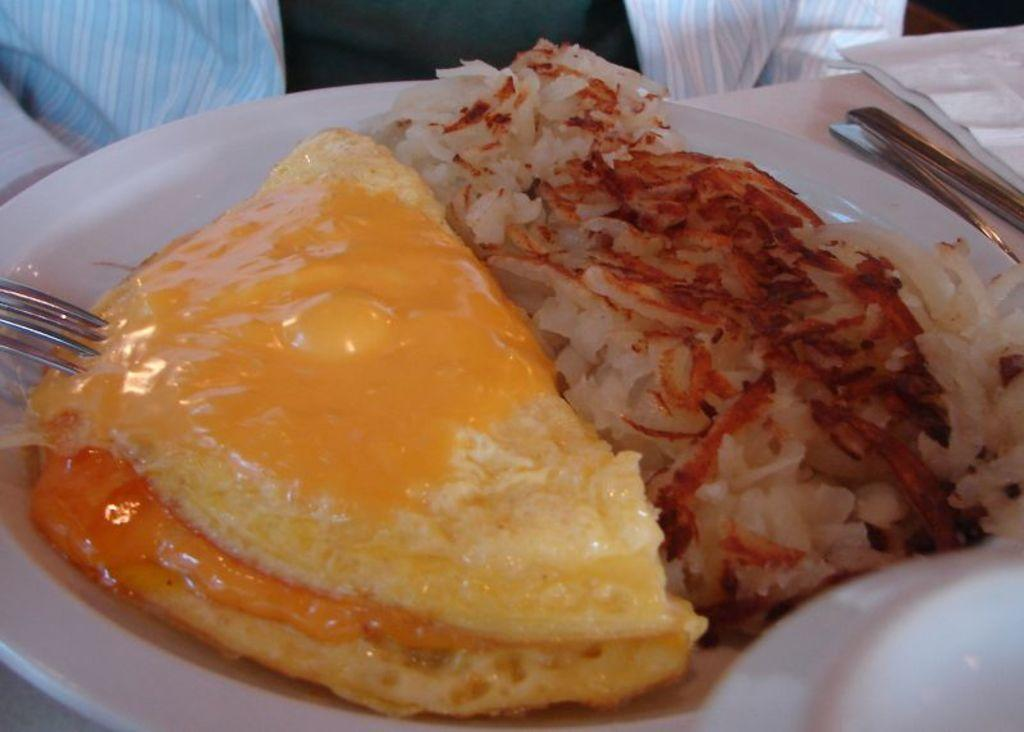What is on the plate that is visible in the image? There is a food item on the plate in the image. What utensils are present in the image? Fork spoons are visible in the image. How many snakes are slithering on the plate in the image? There are no snakes present in the image; it features a plate with a food item and fork spoons. What type of pipe can be seen connected to the food item in the image? There is no pipe connected to the food item in the image. 